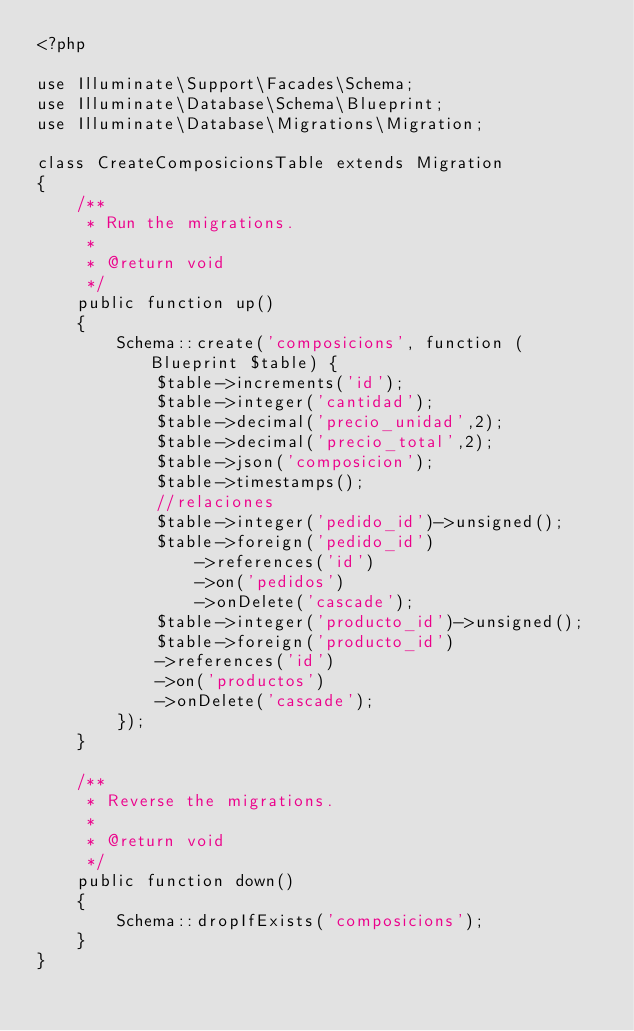<code> <loc_0><loc_0><loc_500><loc_500><_PHP_><?php

use Illuminate\Support\Facades\Schema;
use Illuminate\Database\Schema\Blueprint;
use Illuminate\Database\Migrations\Migration;

class CreateComposicionsTable extends Migration
{
    /**
     * Run the migrations.
     *
     * @return void
     */
    public function up()
    {
        Schema::create('composicions', function (Blueprint $table) {
            $table->increments('id');
            $table->integer('cantidad');
            $table->decimal('precio_unidad',2);
            $table->decimal('precio_total',2);
            $table->json('composicion');
            $table->timestamps();
            //relaciones
            $table->integer('pedido_id')->unsigned();
            $table->foreign('pedido_id')
                ->references('id')
                ->on('pedidos')
                ->onDelete('cascade');
            $table->integer('producto_id')->unsigned();
            $table->foreign('producto_id')
            ->references('id')
            ->on('productos')
            ->onDelete('cascade');
        });
    }

    /**
     * Reverse the migrations.
     *
     * @return void
     */
    public function down()
    {
        Schema::dropIfExists('composicions');
    }
}
</code> 